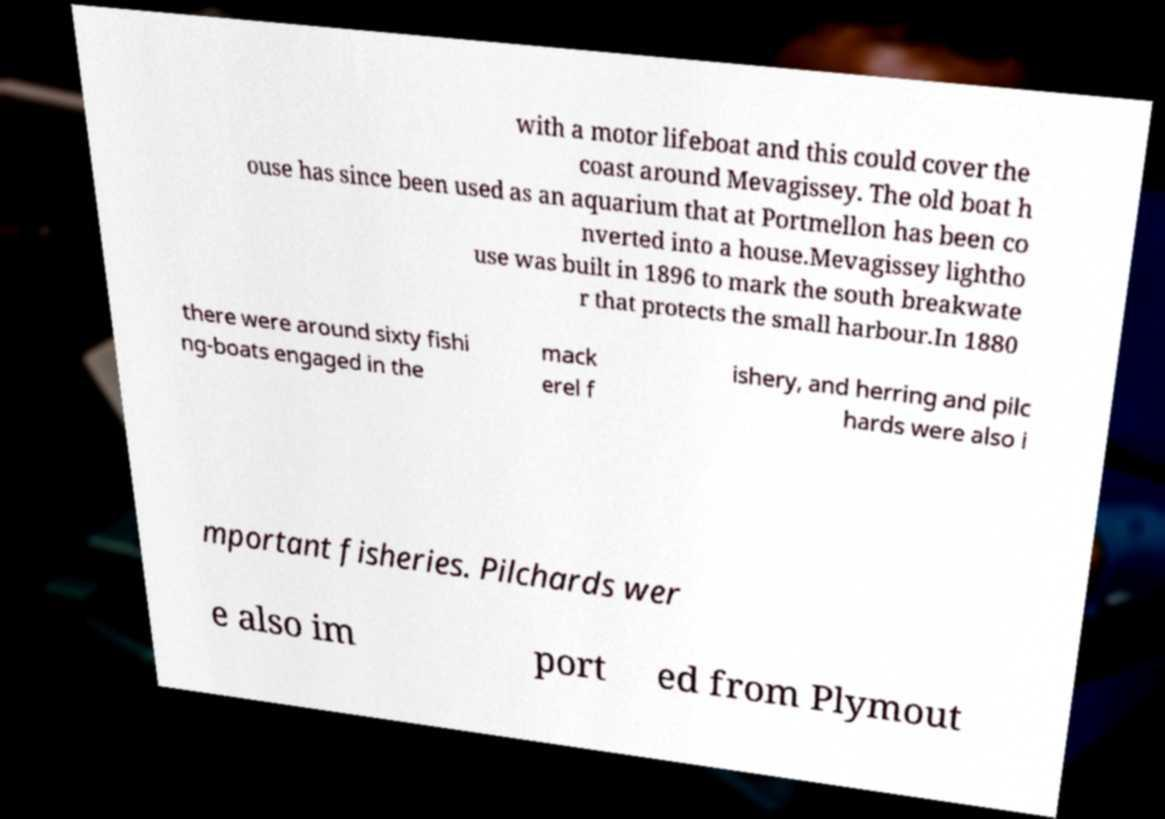Could you extract and type out the text from this image? with a motor lifeboat and this could cover the coast around Mevagissey. The old boat h ouse has since been used as an aquarium that at Portmellon has been co nverted into a house.Mevagissey lightho use was built in 1896 to mark the south breakwate r that protects the small harbour.In 1880 there were around sixty fishi ng-boats engaged in the mack erel f ishery, and herring and pilc hards were also i mportant fisheries. Pilchards wer e also im port ed from Plymout 